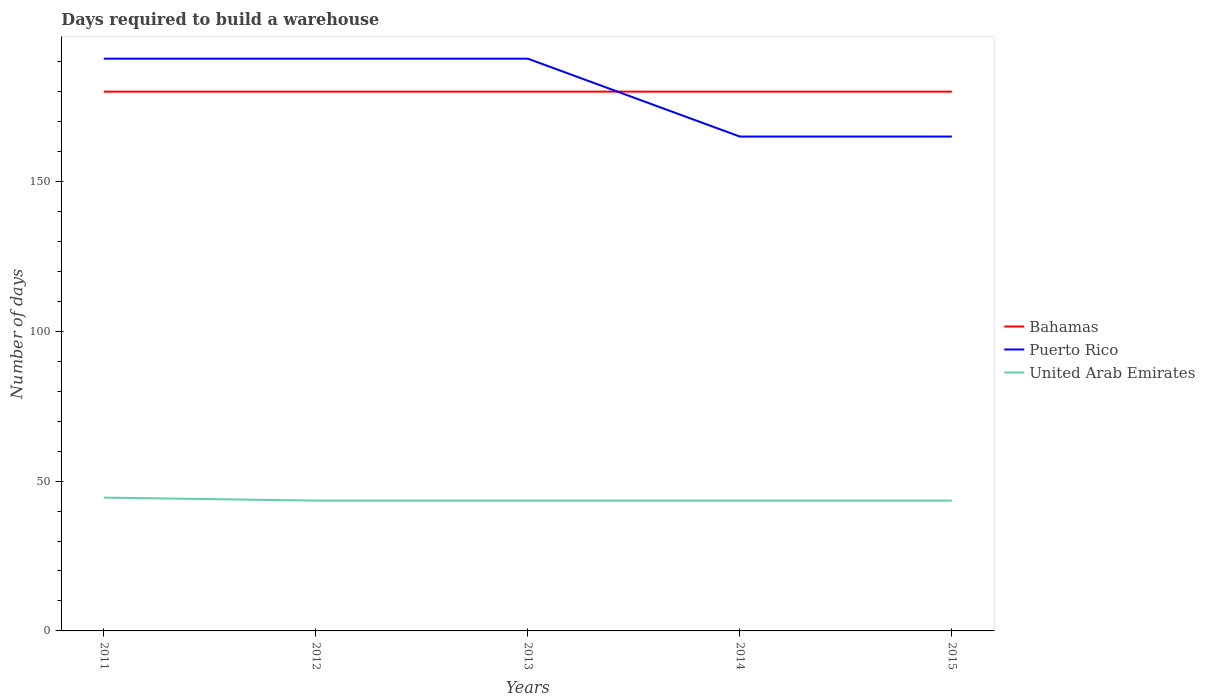Is the number of lines equal to the number of legend labels?
Keep it short and to the point. Yes. Across all years, what is the maximum days required to build a warehouse in in United Arab Emirates?
Give a very brief answer. 43.5. What is the total days required to build a warehouse in in Puerto Rico in the graph?
Provide a short and direct response. 26. What is the difference between the highest and the lowest days required to build a warehouse in in United Arab Emirates?
Your response must be concise. 1. Is the days required to build a warehouse in in United Arab Emirates strictly greater than the days required to build a warehouse in in Puerto Rico over the years?
Your response must be concise. Yes. How many years are there in the graph?
Your answer should be very brief. 5. What is the difference between two consecutive major ticks on the Y-axis?
Provide a succinct answer. 50. Are the values on the major ticks of Y-axis written in scientific E-notation?
Provide a short and direct response. No. Does the graph contain grids?
Ensure brevity in your answer.  No. Where does the legend appear in the graph?
Offer a very short reply. Center right. What is the title of the graph?
Ensure brevity in your answer.  Days required to build a warehouse. What is the label or title of the X-axis?
Provide a short and direct response. Years. What is the label or title of the Y-axis?
Make the answer very short. Number of days. What is the Number of days of Bahamas in 2011?
Offer a very short reply. 180. What is the Number of days of Puerto Rico in 2011?
Offer a very short reply. 191. What is the Number of days in United Arab Emirates in 2011?
Ensure brevity in your answer.  44.5. What is the Number of days of Bahamas in 2012?
Your answer should be compact. 180. What is the Number of days of Puerto Rico in 2012?
Offer a terse response. 191. What is the Number of days of United Arab Emirates in 2012?
Provide a succinct answer. 43.5. What is the Number of days of Bahamas in 2013?
Make the answer very short. 180. What is the Number of days of Puerto Rico in 2013?
Offer a very short reply. 191. What is the Number of days in United Arab Emirates in 2013?
Provide a short and direct response. 43.5. What is the Number of days in Bahamas in 2014?
Provide a succinct answer. 180. What is the Number of days in Puerto Rico in 2014?
Give a very brief answer. 165. What is the Number of days in United Arab Emirates in 2014?
Make the answer very short. 43.5. What is the Number of days of Bahamas in 2015?
Offer a very short reply. 180. What is the Number of days of Puerto Rico in 2015?
Give a very brief answer. 165. What is the Number of days of United Arab Emirates in 2015?
Offer a very short reply. 43.5. Across all years, what is the maximum Number of days in Bahamas?
Keep it short and to the point. 180. Across all years, what is the maximum Number of days of Puerto Rico?
Provide a succinct answer. 191. Across all years, what is the maximum Number of days in United Arab Emirates?
Offer a very short reply. 44.5. Across all years, what is the minimum Number of days in Bahamas?
Your answer should be compact. 180. Across all years, what is the minimum Number of days of Puerto Rico?
Offer a terse response. 165. Across all years, what is the minimum Number of days of United Arab Emirates?
Your response must be concise. 43.5. What is the total Number of days of Bahamas in the graph?
Keep it short and to the point. 900. What is the total Number of days in Puerto Rico in the graph?
Make the answer very short. 903. What is the total Number of days in United Arab Emirates in the graph?
Your answer should be very brief. 218.5. What is the difference between the Number of days in Bahamas in 2011 and that in 2012?
Make the answer very short. 0. What is the difference between the Number of days of Puerto Rico in 2011 and that in 2012?
Give a very brief answer. 0. What is the difference between the Number of days of United Arab Emirates in 2011 and that in 2012?
Offer a terse response. 1. What is the difference between the Number of days of United Arab Emirates in 2011 and that in 2013?
Give a very brief answer. 1. What is the difference between the Number of days of Puerto Rico in 2011 and that in 2014?
Your answer should be very brief. 26. What is the difference between the Number of days of United Arab Emirates in 2011 and that in 2014?
Offer a very short reply. 1. What is the difference between the Number of days in Bahamas in 2011 and that in 2015?
Provide a succinct answer. 0. What is the difference between the Number of days in Puerto Rico in 2011 and that in 2015?
Provide a succinct answer. 26. What is the difference between the Number of days in United Arab Emirates in 2011 and that in 2015?
Your response must be concise. 1. What is the difference between the Number of days in Puerto Rico in 2012 and that in 2013?
Your answer should be very brief. 0. What is the difference between the Number of days in United Arab Emirates in 2012 and that in 2013?
Give a very brief answer. 0. What is the difference between the Number of days in Bahamas in 2012 and that in 2014?
Provide a short and direct response. 0. What is the difference between the Number of days in Puerto Rico in 2012 and that in 2014?
Your response must be concise. 26. What is the difference between the Number of days of Bahamas in 2013 and that in 2014?
Provide a succinct answer. 0. What is the difference between the Number of days in Puerto Rico in 2013 and that in 2014?
Ensure brevity in your answer.  26. What is the difference between the Number of days of United Arab Emirates in 2013 and that in 2014?
Make the answer very short. 0. What is the difference between the Number of days in Bahamas in 2013 and that in 2015?
Offer a terse response. 0. What is the difference between the Number of days in United Arab Emirates in 2013 and that in 2015?
Make the answer very short. 0. What is the difference between the Number of days in Bahamas in 2014 and that in 2015?
Provide a short and direct response. 0. What is the difference between the Number of days in United Arab Emirates in 2014 and that in 2015?
Ensure brevity in your answer.  0. What is the difference between the Number of days in Bahamas in 2011 and the Number of days in United Arab Emirates in 2012?
Keep it short and to the point. 136.5. What is the difference between the Number of days in Puerto Rico in 2011 and the Number of days in United Arab Emirates in 2012?
Your response must be concise. 147.5. What is the difference between the Number of days in Bahamas in 2011 and the Number of days in United Arab Emirates in 2013?
Ensure brevity in your answer.  136.5. What is the difference between the Number of days in Puerto Rico in 2011 and the Number of days in United Arab Emirates in 2013?
Your answer should be compact. 147.5. What is the difference between the Number of days of Bahamas in 2011 and the Number of days of Puerto Rico in 2014?
Provide a succinct answer. 15. What is the difference between the Number of days of Bahamas in 2011 and the Number of days of United Arab Emirates in 2014?
Keep it short and to the point. 136.5. What is the difference between the Number of days of Puerto Rico in 2011 and the Number of days of United Arab Emirates in 2014?
Give a very brief answer. 147.5. What is the difference between the Number of days of Bahamas in 2011 and the Number of days of Puerto Rico in 2015?
Offer a very short reply. 15. What is the difference between the Number of days in Bahamas in 2011 and the Number of days in United Arab Emirates in 2015?
Give a very brief answer. 136.5. What is the difference between the Number of days in Puerto Rico in 2011 and the Number of days in United Arab Emirates in 2015?
Make the answer very short. 147.5. What is the difference between the Number of days in Bahamas in 2012 and the Number of days in Puerto Rico in 2013?
Your answer should be very brief. -11. What is the difference between the Number of days of Bahamas in 2012 and the Number of days of United Arab Emirates in 2013?
Make the answer very short. 136.5. What is the difference between the Number of days in Puerto Rico in 2012 and the Number of days in United Arab Emirates in 2013?
Provide a short and direct response. 147.5. What is the difference between the Number of days of Bahamas in 2012 and the Number of days of United Arab Emirates in 2014?
Make the answer very short. 136.5. What is the difference between the Number of days in Puerto Rico in 2012 and the Number of days in United Arab Emirates in 2014?
Provide a succinct answer. 147.5. What is the difference between the Number of days in Bahamas in 2012 and the Number of days in United Arab Emirates in 2015?
Provide a short and direct response. 136.5. What is the difference between the Number of days of Puerto Rico in 2012 and the Number of days of United Arab Emirates in 2015?
Offer a terse response. 147.5. What is the difference between the Number of days in Bahamas in 2013 and the Number of days in United Arab Emirates in 2014?
Make the answer very short. 136.5. What is the difference between the Number of days of Puerto Rico in 2013 and the Number of days of United Arab Emirates in 2014?
Provide a succinct answer. 147.5. What is the difference between the Number of days of Bahamas in 2013 and the Number of days of United Arab Emirates in 2015?
Provide a succinct answer. 136.5. What is the difference between the Number of days in Puerto Rico in 2013 and the Number of days in United Arab Emirates in 2015?
Give a very brief answer. 147.5. What is the difference between the Number of days in Bahamas in 2014 and the Number of days in Puerto Rico in 2015?
Offer a very short reply. 15. What is the difference between the Number of days in Bahamas in 2014 and the Number of days in United Arab Emirates in 2015?
Your answer should be compact. 136.5. What is the difference between the Number of days of Puerto Rico in 2014 and the Number of days of United Arab Emirates in 2015?
Ensure brevity in your answer.  121.5. What is the average Number of days in Bahamas per year?
Provide a short and direct response. 180. What is the average Number of days of Puerto Rico per year?
Your answer should be very brief. 180.6. What is the average Number of days in United Arab Emirates per year?
Provide a succinct answer. 43.7. In the year 2011, what is the difference between the Number of days in Bahamas and Number of days in United Arab Emirates?
Your answer should be very brief. 135.5. In the year 2011, what is the difference between the Number of days of Puerto Rico and Number of days of United Arab Emirates?
Your answer should be very brief. 146.5. In the year 2012, what is the difference between the Number of days of Bahamas and Number of days of Puerto Rico?
Provide a succinct answer. -11. In the year 2012, what is the difference between the Number of days in Bahamas and Number of days in United Arab Emirates?
Give a very brief answer. 136.5. In the year 2012, what is the difference between the Number of days in Puerto Rico and Number of days in United Arab Emirates?
Keep it short and to the point. 147.5. In the year 2013, what is the difference between the Number of days of Bahamas and Number of days of Puerto Rico?
Keep it short and to the point. -11. In the year 2013, what is the difference between the Number of days of Bahamas and Number of days of United Arab Emirates?
Your answer should be compact. 136.5. In the year 2013, what is the difference between the Number of days in Puerto Rico and Number of days in United Arab Emirates?
Make the answer very short. 147.5. In the year 2014, what is the difference between the Number of days of Bahamas and Number of days of United Arab Emirates?
Provide a short and direct response. 136.5. In the year 2014, what is the difference between the Number of days in Puerto Rico and Number of days in United Arab Emirates?
Your response must be concise. 121.5. In the year 2015, what is the difference between the Number of days of Bahamas and Number of days of United Arab Emirates?
Your response must be concise. 136.5. In the year 2015, what is the difference between the Number of days of Puerto Rico and Number of days of United Arab Emirates?
Keep it short and to the point. 121.5. What is the ratio of the Number of days in Bahamas in 2011 to that in 2012?
Give a very brief answer. 1. What is the ratio of the Number of days in Puerto Rico in 2011 to that in 2012?
Your answer should be compact. 1. What is the ratio of the Number of days of United Arab Emirates in 2011 to that in 2012?
Your answer should be very brief. 1.02. What is the ratio of the Number of days in Bahamas in 2011 to that in 2013?
Provide a short and direct response. 1. What is the ratio of the Number of days of Puerto Rico in 2011 to that in 2014?
Give a very brief answer. 1.16. What is the ratio of the Number of days in United Arab Emirates in 2011 to that in 2014?
Provide a short and direct response. 1.02. What is the ratio of the Number of days of Bahamas in 2011 to that in 2015?
Give a very brief answer. 1. What is the ratio of the Number of days of Puerto Rico in 2011 to that in 2015?
Give a very brief answer. 1.16. What is the ratio of the Number of days of United Arab Emirates in 2011 to that in 2015?
Offer a terse response. 1.02. What is the ratio of the Number of days of Bahamas in 2012 to that in 2013?
Ensure brevity in your answer.  1. What is the ratio of the Number of days of Puerto Rico in 2012 to that in 2013?
Your answer should be compact. 1. What is the ratio of the Number of days of Bahamas in 2012 to that in 2014?
Your response must be concise. 1. What is the ratio of the Number of days in Puerto Rico in 2012 to that in 2014?
Your answer should be compact. 1.16. What is the ratio of the Number of days in United Arab Emirates in 2012 to that in 2014?
Provide a short and direct response. 1. What is the ratio of the Number of days in Puerto Rico in 2012 to that in 2015?
Your answer should be very brief. 1.16. What is the ratio of the Number of days of Puerto Rico in 2013 to that in 2014?
Ensure brevity in your answer.  1.16. What is the ratio of the Number of days in Puerto Rico in 2013 to that in 2015?
Give a very brief answer. 1.16. What is the ratio of the Number of days in Bahamas in 2014 to that in 2015?
Offer a very short reply. 1. What is the ratio of the Number of days in Puerto Rico in 2014 to that in 2015?
Your answer should be very brief. 1. What is the difference between the highest and the second highest Number of days in Bahamas?
Your answer should be very brief. 0. What is the difference between the highest and the second highest Number of days of Puerto Rico?
Provide a succinct answer. 0. What is the difference between the highest and the lowest Number of days of Puerto Rico?
Keep it short and to the point. 26. 